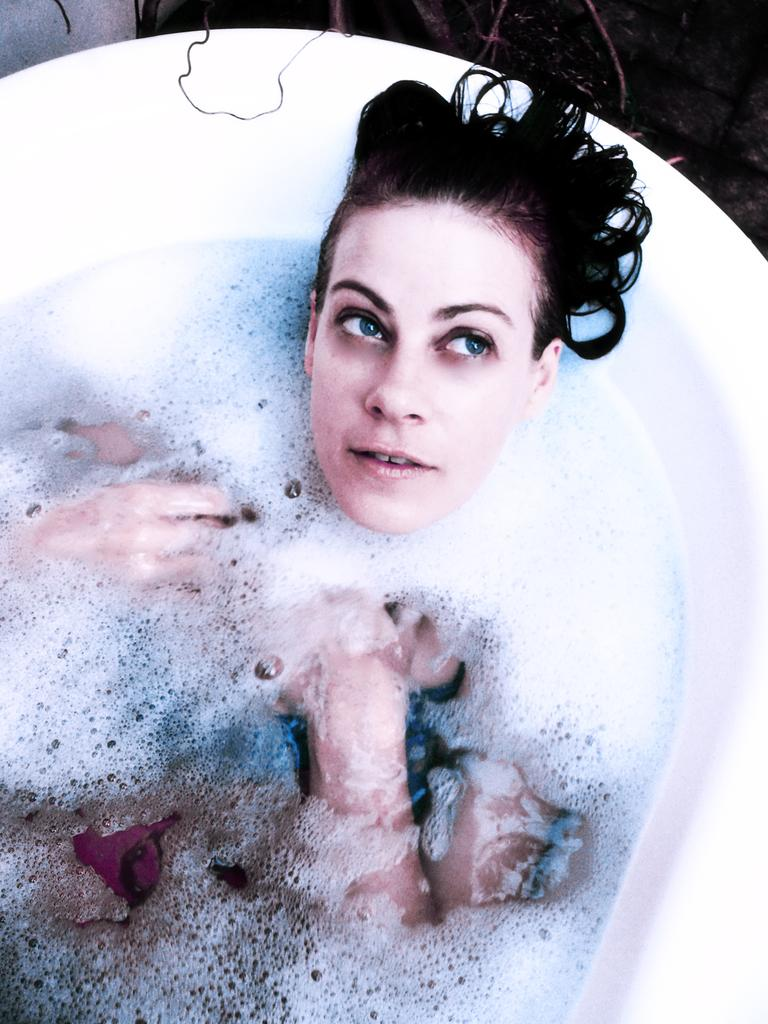What color is the bathtub in the image? The bathtub in the image is white colored. What is inside the bathtub? There is water and foam in the bathtub. Is there anyone in the bathtub? Yes, there is a person in the bathtub. What is the person wearing? The person is wearing a blue and black colored dress. What type of account is being discussed in the image? There is no discussion or account present in the image; it features a person in a bathtub with water and foam. 